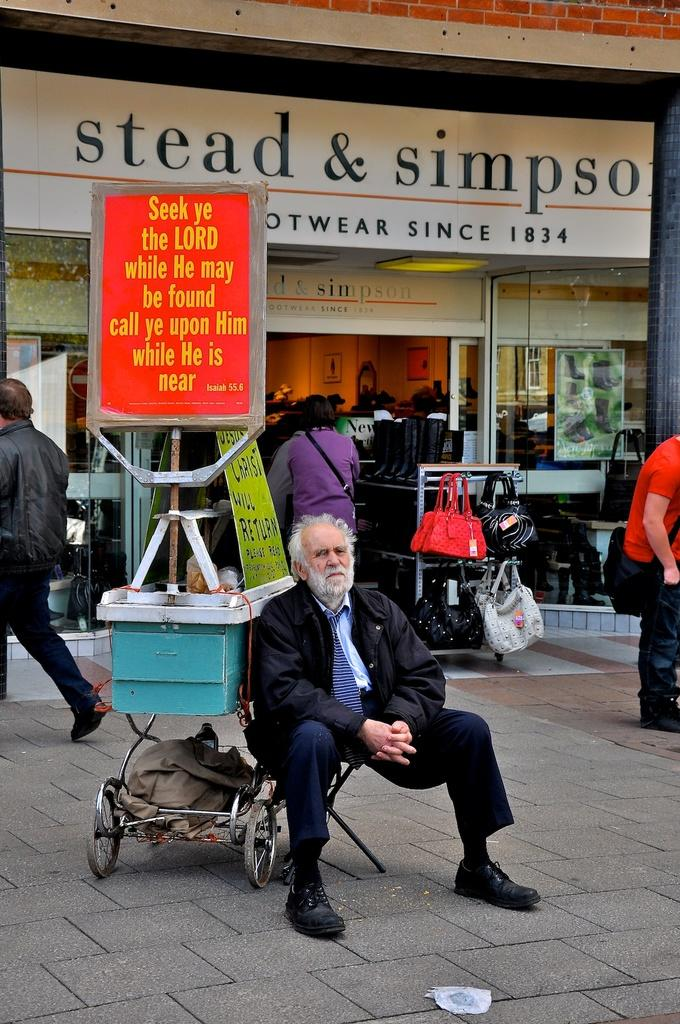What type of display can be seen in the image? There is a poster and a banner in the image. What is the man in the image doing? There is a man sitting in the image. What type of establishment is visible in the image? There is a shop visible in the image. What items might be used for carrying or holding items in the image? There are bags present in the image. What type of oil can be seen dripping from the banner in the image? There is no oil present in the image, and the banner is not depicted as dripping anything. 